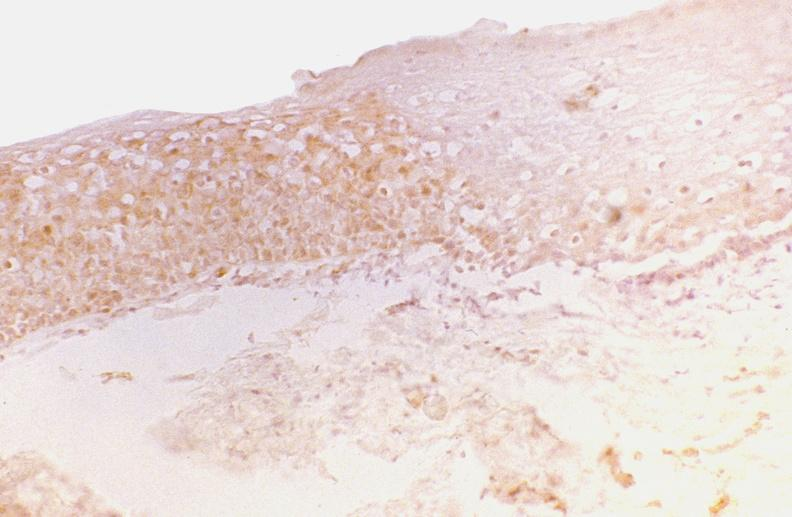s gastrointestinal present?
Answer the question using a single word or phrase. Yes 